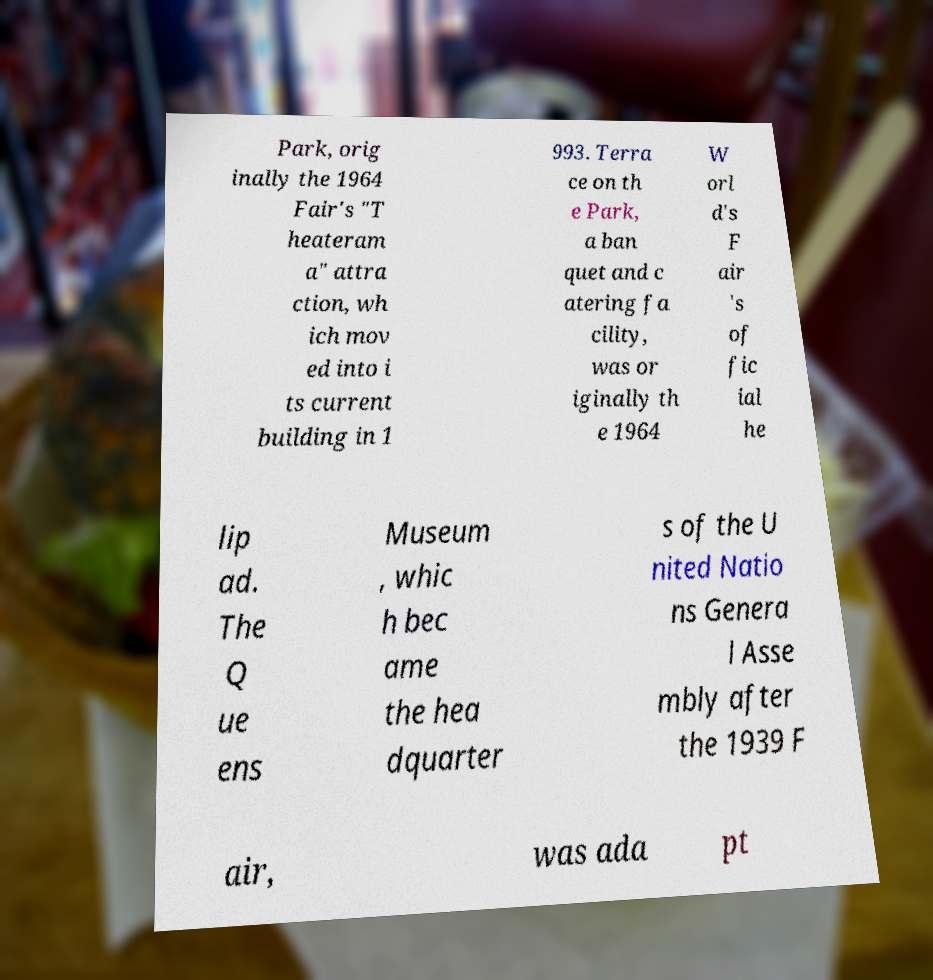Could you assist in decoding the text presented in this image and type it out clearly? Park, orig inally the 1964 Fair's "T heateram a" attra ction, wh ich mov ed into i ts current building in 1 993. Terra ce on th e Park, a ban quet and c atering fa cility, was or iginally th e 1964 W orl d's F air 's of fic ial he lip ad. The Q ue ens Museum , whic h bec ame the hea dquarter s of the U nited Natio ns Genera l Asse mbly after the 1939 F air, was ada pt 